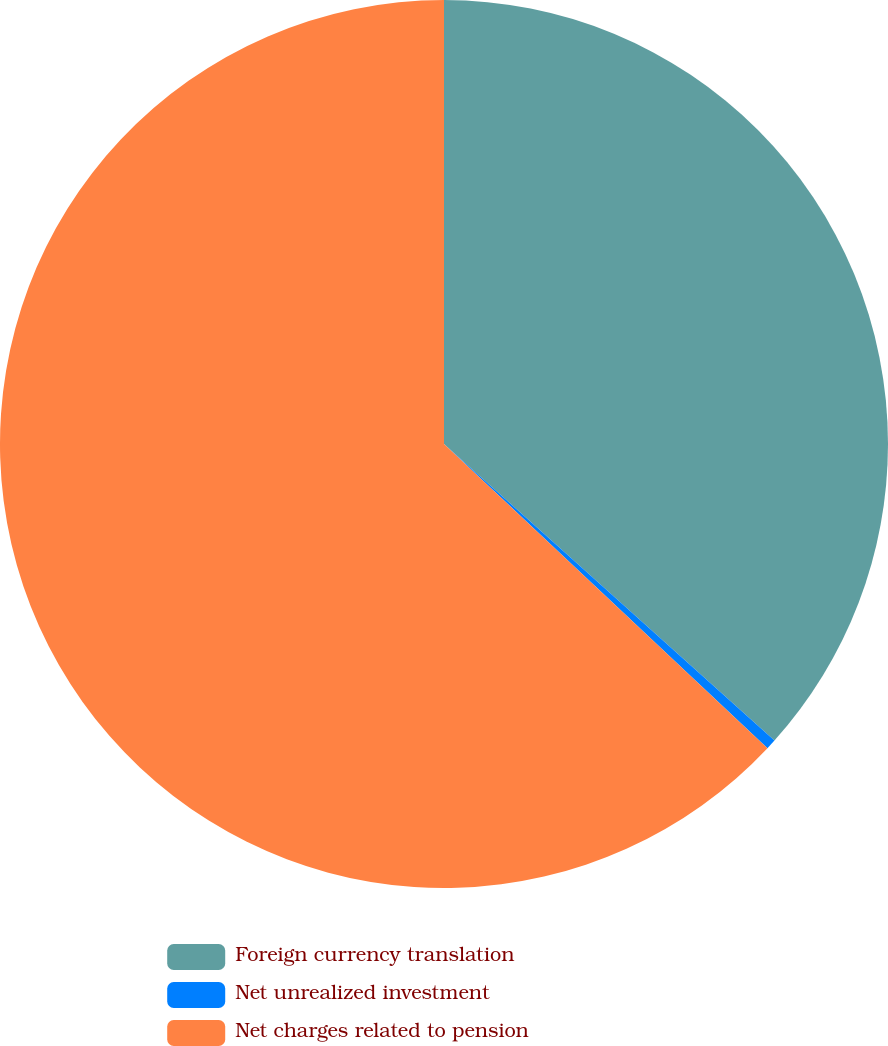<chart> <loc_0><loc_0><loc_500><loc_500><pie_chart><fcel>Foreign currency translation<fcel>Net unrealized investment<fcel>Net charges related to pension<nl><fcel>36.64%<fcel>0.37%<fcel>62.99%<nl></chart> 